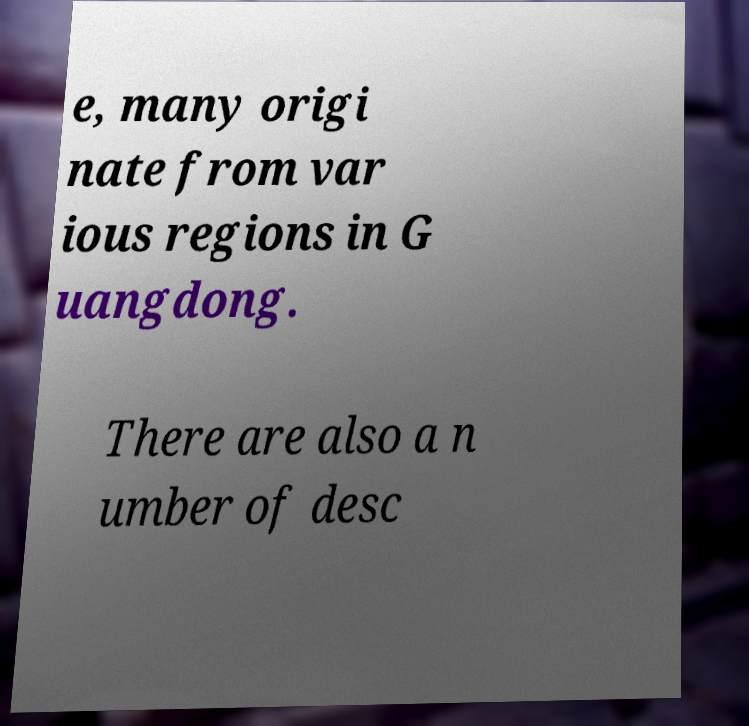What messages or text are displayed in this image? I need them in a readable, typed format. e, many origi nate from var ious regions in G uangdong. There are also a n umber of desc 